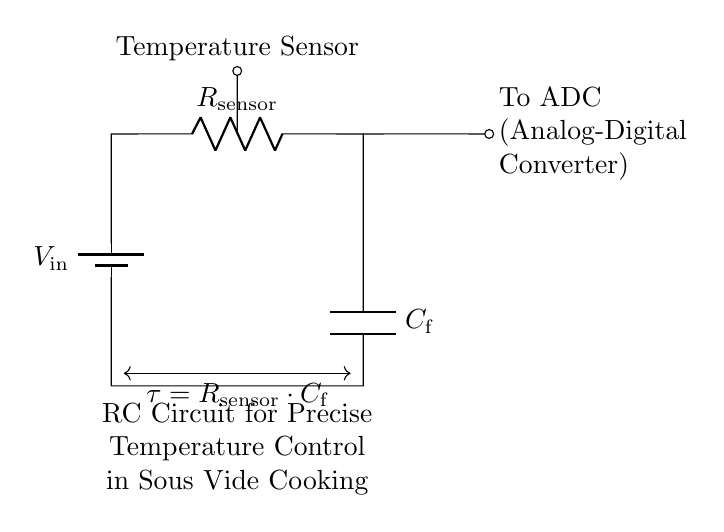What type of circuit is depicted? The circuit is an RC (Resistor-Capacitor) circuit, which consists of a resistor and a capacitor connected in series. This type of circuit is often used for timing and filtering applications.
Answer: RC circuit What does R represent in this circuit? R represents the temperature sensor resistor, which is crucial for determining the resistance based on temperature. In this circuit, it converts the temperature changes into varying voltage levels across the capacitor.
Answer: R sensor What is the role of C in this circuit? C represents the filter capacitor, which smooths out the voltage readings from the temperature sensor to provide a stable output to the ADC. Capacitors store and release energy, helping to maintain a steady voltage level.
Answer: C filter What does ADC stand for in this context? ADC stands for Analog-Digital Converter, which is an electronic device that converts the analog voltage signal output from the RC circuit into a digital signal that can be processed by a microcontroller or computer.
Answer: ADC What is the time constant for this circuit? The time constant τ is calculated as the product of R and C (τ = R sensor * C f). It represents the time it takes for the capacitor to charge to about 63.2% of its maximum voltage when subjected to a step voltage.
Answer: R sensor * C f How does this RC circuit maintain precise temperature control? The RC circuit maintains precise temperature control by filtering and stabilizing the voltage signal from the temperature sensor, allowing for accurate readings that are essential for controlling heating elements in sous vide cooking appliances. The steady voltage helps the control system adjust the heating based on the desired temperature.
Answer: Filtering and stabilizing How can variations in R affect the circuit's performance? Variations in R, which is influenced by temperature changes, directly impact the circuit's time constant τ and the charging/discharging behavior of the capacitor C. A higher R increases the time constant, slowing the response of the circuit, while a lower R causes a faster response. This affects how quickly the system can react to temperature changes.
Answer: Affects time constant 